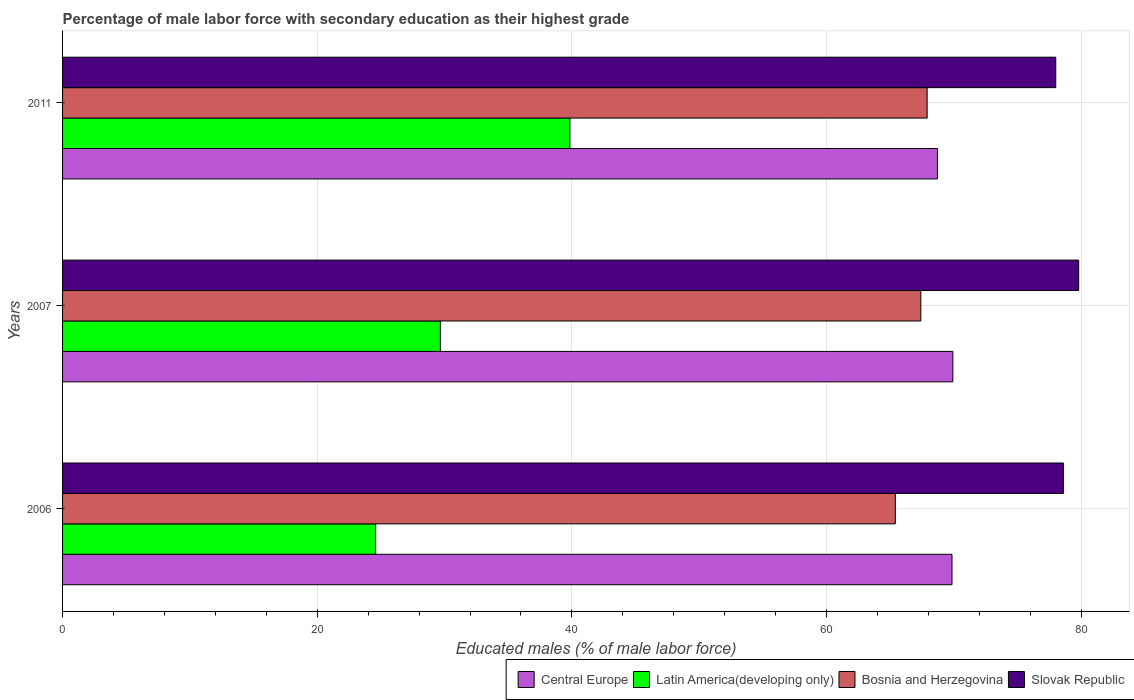Are the number of bars per tick equal to the number of legend labels?
Make the answer very short. Yes. How many bars are there on the 2nd tick from the top?
Keep it short and to the point. 4. In how many cases, is the number of bars for a given year not equal to the number of legend labels?
Offer a very short reply. 0. What is the percentage of male labor force with secondary education in Bosnia and Herzegovina in 2006?
Your answer should be compact. 65.4. Across all years, what is the maximum percentage of male labor force with secondary education in Bosnia and Herzegovina?
Your answer should be compact. 67.9. In which year was the percentage of male labor force with secondary education in Central Europe maximum?
Offer a terse response. 2007. What is the total percentage of male labor force with secondary education in Bosnia and Herzegovina in the graph?
Ensure brevity in your answer.  200.7. What is the difference between the percentage of male labor force with secondary education in Slovak Republic in 2007 and that in 2011?
Give a very brief answer. 1.8. What is the difference between the percentage of male labor force with secondary education in Latin America(developing only) in 2006 and the percentage of male labor force with secondary education in Slovak Republic in 2011?
Offer a very short reply. -53.41. What is the average percentage of male labor force with secondary education in Bosnia and Herzegovina per year?
Your response must be concise. 66.9. In the year 2007, what is the difference between the percentage of male labor force with secondary education in Bosnia and Herzegovina and percentage of male labor force with secondary education in Slovak Republic?
Offer a very short reply. -12.4. In how many years, is the percentage of male labor force with secondary education in Central Europe greater than 48 %?
Offer a very short reply. 3. What is the ratio of the percentage of male labor force with secondary education in Slovak Republic in 2007 to that in 2011?
Your response must be concise. 1.02. Is the percentage of male labor force with secondary education in Central Europe in 2007 less than that in 2011?
Your response must be concise. No. What is the difference between the highest and the second highest percentage of male labor force with secondary education in Bosnia and Herzegovina?
Offer a very short reply. 0.5. What is the difference between the highest and the lowest percentage of male labor force with secondary education in Latin America(developing only)?
Offer a very short reply. 15.25. In how many years, is the percentage of male labor force with secondary education in Bosnia and Herzegovina greater than the average percentage of male labor force with secondary education in Bosnia and Herzegovina taken over all years?
Give a very brief answer. 2. Is the sum of the percentage of male labor force with secondary education in Bosnia and Herzegovina in 2006 and 2007 greater than the maximum percentage of male labor force with secondary education in Central Europe across all years?
Provide a succinct answer. Yes. What does the 4th bar from the top in 2011 represents?
Offer a very short reply. Central Europe. What does the 4th bar from the bottom in 2011 represents?
Your response must be concise. Slovak Republic. Is it the case that in every year, the sum of the percentage of male labor force with secondary education in Latin America(developing only) and percentage of male labor force with secondary education in Slovak Republic is greater than the percentage of male labor force with secondary education in Bosnia and Herzegovina?
Offer a very short reply. Yes. How are the legend labels stacked?
Your answer should be compact. Horizontal. What is the title of the graph?
Give a very brief answer. Percentage of male labor force with secondary education as their highest grade. Does "Pacific island small states" appear as one of the legend labels in the graph?
Provide a short and direct response. No. What is the label or title of the X-axis?
Keep it short and to the point. Educated males (% of male labor force). What is the Educated males (% of male labor force) in Central Europe in 2006?
Ensure brevity in your answer.  69.85. What is the Educated males (% of male labor force) in Latin America(developing only) in 2006?
Your response must be concise. 24.59. What is the Educated males (% of male labor force) of Bosnia and Herzegovina in 2006?
Your answer should be compact. 65.4. What is the Educated males (% of male labor force) of Slovak Republic in 2006?
Provide a succinct answer. 78.6. What is the Educated males (% of male labor force) in Central Europe in 2007?
Make the answer very short. 69.92. What is the Educated males (% of male labor force) of Latin America(developing only) in 2007?
Give a very brief answer. 29.67. What is the Educated males (% of male labor force) in Bosnia and Herzegovina in 2007?
Your answer should be very brief. 67.4. What is the Educated males (% of male labor force) of Slovak Republic in 2007?
Your answer should be very brief. 79.8. What is the Educated males (% of male labor force) of Central Europe in 2011?
Your response must be concise. 68.71. What is the Educated males (% of male labor force) in Latin America(developing only) in 2011?
Provide a succinct answer. 39.84. What is the Educated males (% of male labor force) of Bosnia and Herzegovina in 2011?
Provide a succinct answer. 67.9. Across all years, what is the maximum Educated males (% of male labor force) of Central Europe?
Offer a very short reply. 69.92. Across all years, what is the maximum Educated males (% of male labor force) of Latin America(developing only)?
Provide a succinct answer. 39.84. Across all years, what is the maximum Educated males (% of male labor force) of Bosnia and Herzegovina?
Provide a succinct answer. 67.9. Across all years, what is the maximum Educated males (% of male labor force) in Slovak Republic?
Your answer should be compact. 79.8. Across all years, what is the minimum Educated males (% of male labor force) of Central Europe?
Your response must be concise. 68.71. Across all years, what is the minimum Educated males (% of male labor force) in Latin America(developing only)?
Your response must be concise. 24.59. Across all years, what is the minimum Educated males (% of male labor force) of Bosnia and Herzegovina?
Provide a short and direct response. 65.4. Across all years, what is the minimum Educated males (% of male labor force) in Slovak Republic?
Keep it short and to the point. 78. What is the total Educated males (% of male labor force) in Central Europe in the graph?
Make the answer very short. 208.48. What is the total Educated males (% of male labor force) in Latin America(developing only) in the graph?
Keep it short and to the point. 94.1. What is the total Educated males (% of male labor force) in Bosnia and Herzegovina in the graph?
Offer a very short reply. 200.7. What is the total Educated males (% of male labor force) of Slovak Republic in the graph?
Make the answer very short. 236.4. What is the difference between the Educated males (% of male labor force) of Central Europe in 2006 and that in 2007?
Offer a terse response. -0.07. What is the difference between the Educated males (% of male labor force) in Latin America(developing only) in 2006 and that in 2007?
Give a very brief answer. -5.08. What is the difference between the Educated males (% of male labor force) of Central Europe in 2006 and that in 2011?
Offer a very short reply. 1.14. What is the difference between the Educated males (% of male labor force) in Latin America(developing only) in 2006 and that in 2011?
Provide a short and direct response. -15.25. What is the difference between the Educated males (% of male labor force) of Central Europe in 2007 and that in 2011?
Offer a terse response. 1.21. What is the difference between the Educated males (% of male labor force) of Latin America(developing only) in 2007 and that in 2011?
Your answer should be compact. -10.17. What is the difference between the Educated males (% of male labor force) in Central Europe in 2006 and the Educated males (% of male labor force) in Latin America(developing only) in 2007?
Your answer should be very brief. 40.18. What is the difference between the Educated males (% of male labor force) in Central Europe in 2006 and the Educated males (% of male labor force) in Bosnia and Herzegovina in 2007?
Offer a terse response. 2.45. What is the difference between the Educated males (% of male labor force) of Central Europe in 2006 and the Educated males (% of male labor force) of Slovak Republic in 2007?
Provide a succinct answer. -9.95. What is the difference between the Educated males (% of male labor force) in Latin America(developing only) in 2006 and the Educated males (% of male labor force) in Bosnia and Herzegovina in 2007?
Your answer should be compact. -42.81. What is the difference between the Educated males (% of male labor force) of Latin America(developing only) in 2006 and the Educated males (% of male labor force) of Slovak Republic in 2007?
Keep it short and to the point. -55.21. What is the difference between the Educated males (% of male labor force) of Bosnia and Herzegovina in 2006 and the Educated males (% of male labor force) of Slovak Republic in 2007?
Keep it short and to the point. -14.4. What is the difference between the Educated males (% of male labor force) of Central Europe in 2006 and the Educated males (% of male labor force) of Latin America(developing only) in 2011?
Offer a very short reply. 30.01. What is the difference between the Educated males (% of male labor force) in Central Europe in 2006 and the Educated males (% of male labor force) in Bosnia and Herzegovina in 2011?
Your response must be concise. 1.95. What is the difference between the Educated males (% of male labor force) in Central Europe in 2006 and the Educated males (% of male labor force) in Slovak Republic in 2011?
Offer a very short reply. -8.15. What is the difference between the Educated males (% of male labor force) in Latin America(developing only) in 2006 and the Educated males (% of male labor force) in Bosnia and Herzegovina in 2011?
Offer a very short reply. -43.31. What is the difference between the Educated males (% of male labor force) in Latin America(developing only) in 2006 and the Educated males (% of male labor force) in Slovak Republic in 2011?
Offer a very short reply. -53.41. What is the difference between the Educated males (% of male labor force) in Central Europe in 2007 and the Educated males (% of male labor force) in Latin America(developing only) in 2011?
Your response must be concise. 30.08. What is the difference between the Educated males (% of male labor force) of Central Europe in 2007 and the Educated males (% of male labor force) of Bosnia and Herzegovina in 2011?
Your response must be concise. 2.02. What is the difference between the Educated males (% of male labor force) in Central Europe in 2007 and the Educated males (% of male labor force) in Slovak Republic in 2011?
Offer a terse response. -8.08. What is the difference between the Educated males (% of male labor force) of Latin America(developing only) in 2007 and the Educated males (% of male labor force) of Bosnia and Herzegovina in 2011?
Keep it short and to the point. -38.23. What is the difference between the Educated males (% of male labor force) of Latin America(developing only) in 2007 and the Educated males (% of male labor force) of Slovak Republic in 2011?
Your answer should be very brief. -48.33. What is the difference between the Educated males (% of male labor force) of Bosnia and Herzegovina in 2007 and the Educated males (% of male labor force) of Slovak Republic in 2011?
Provide a succinct answer. -10.6. What is the average Educated males (% of male labor force) of Central Europe per year?
Provide a short and direct response. 69.49. What is the average Educated males (% of male labor force) of Latin America(developing only) per year?
Make the answer very short. 31.37. What is the average Educated males (% of male labor force) in Bosnia and Herzegovina per year?
Keep it short and to the point. 66.9. What is the average Educated males (% of male labor force) in Slovak Republic per year?
Make the answer very short. 78.8. In the year 2006, what is the difference between the Educated males (% of male labor force) of Central Europe and Educated males (% of male labor force) of Latin America(developing only)?
Make the answer very short. 45.26. In the year 2006, what is the difference between the Educated males (% of male labor force) of Central Europe and Educated males (% of male labor force) of Bosnia and Herzegovina?
Your answer should be compact. 4.45. In the year 2006, what is the difference between the Educated males (% of male labor force) of Central Europe and Educated males (% of male labor force) of Slovak Republic?
Provide a succinct answer. -8.75. In the year 2006, what is the difference between the Educated males (% of male labor force) in Latin America(developing only) and Educated males (% of male labor force) in Bosnia and Herzegovina?
Keep it short and to the point. -40.81. In the year 2006, what is the difference between the Educated males (% of male labor force) in Latin America(developing only) and Educated males (% of male labor force) in Slovak Republic?
Provide a succinct answer. -54.01. In the year 2007, what is the difference between the Educated males (% of male labor force) in Central Europe and Educated males (% of male labor force) in Latin America(developing only)?
Provide a short and direct response. 40.25. In the year 2007, what is the difference between the Educated males (% of male labor force) of Central Europe and Educated males (% of male labor force) of Bosnia and Herzegovina?
Your response must be concise. 2.52. In the year 2007, what is the difference between the Educated males (% of male labor force) in Central Europe and Educated males (% of male labor force) in Slovak Republic?
Keep it short and to the point. -9.88. In the year 2007, what is the difference between the Educated males (% of male labor force) in Latin America(developing only) and Educated males (% of male labor force) in Bosnia and Herzegovina?
Offer a very short reply. -37.73. In the year 2007, what is the difference between the Educated males (% of male labor force) in Latin America(developing only) and Educated males (% of male labor force) in Slovak Republic?
Your answer should be compact. -50.13. In the year 2011, what is the difference between the Educated males (% of male labor force) in Central Europe and Educated males (% of male labor force) in Latin America(developing only)?
Your response must be concise. 28.87. In the year 2011, what is the difference between the Educated males (% of male labor force) in Central Europe and Educated males (% of male labor force) in Bosnia and Herzegovina?
Provide a short and direct response. 0.81. In the year 2011, what is the difference between the Educated males (% of male labor force) in Central Europe and Educated males (% of male labor force) in Slovak Republic?
Your answer should be very brief. -9.29. In the year 2011, what is the difference between the Educated males (% of male labor force) of Latin America(developing only) and Educated males (% of male labor force) of Bosnia and Herzegovina?
Your response must be concise. -28.06. In the year 2011, what is the difference between the Educated males (% of male labor force) of Latin America(developing only) and Educated males (% of male labor force) of Slovak Republic?
Keep it short and to the point. -38.16. In the year 2011, what is the difference between the Educated males (% of male labor force) of Bosnia and Herzegovina and Educated males (% of male labor force) of Slovak Republic?
Your response must be concise. -10.1. What is the ratio of the Educated males (% of male labor force) of Central Europe in 2006 to that in 2007?
Make the answer very short. 1. What is the ratio of the Educated males (% of male labor force) of Latin America(developing only) in 2006 to that in 2007?
Give a very brief answer. 0.83. What is the ratio of the Educated males (% of male labor force) in Bosnia and Herzegovina in 2006 to that in 2007?
Give a very brief answer. 0.97. What is the ratio of the Educated males (% of male labor force) in Central Europe in 2006 to that in 2011?
Offer a terse response. 1.02. What is the ratio of the Educated males (% of male labor force) of Latin America(developing only) in 2006 to that in 2011?
Offer a terse response. 0.62. What is the ratio of the Educated males (% of male labor force) in Bosnia and Herzegovina in 2006 to that in 2011?
Ensure brevity in your answer.  0.96. What is the ratio of the Educated males (% of male labor force) in Slovak Republic in 2006 to that in 2011?
Give a very brief answer. 1.01. What is the ratio of the Educated males (% of male labor force) of Central Europe in 2007 to that in 2011?
Offer a very short reply. 1.02. What is the ratio of the Educated males (% of male labor force) of Latin America(developing only) in 2007 to that in 2011?
Offer a very short reply. 0.74. What is the ratio of the Educated males (% of male labor force) of Slovak Republic in 2007 to that in 2011?
Your answer should be very brief. 1.02. What is the difference between the highest and the second highest Educated males (% of male labor force) in Central Europe?
Your response must be concise. 0.07. What is the difference between the highest and the second highest Educated males (% of male labor force) of Latin America(developing only)?
Ensure brevity in your answer.  10.17. What is the difference between the highest and the second highest Educated males (% of male labor force) of Slovak Republic?
Offer a very short reply. 1.2. What is the difference between the highest and the lowest Educated males (% of male labor force) of Central Europe?
Keep it short and to the point. 1.21. What is the difference between the highest and the lowest Educated males (% of male labor force) in Latin America(developing only)?
Make the answer very short. 15.25. 